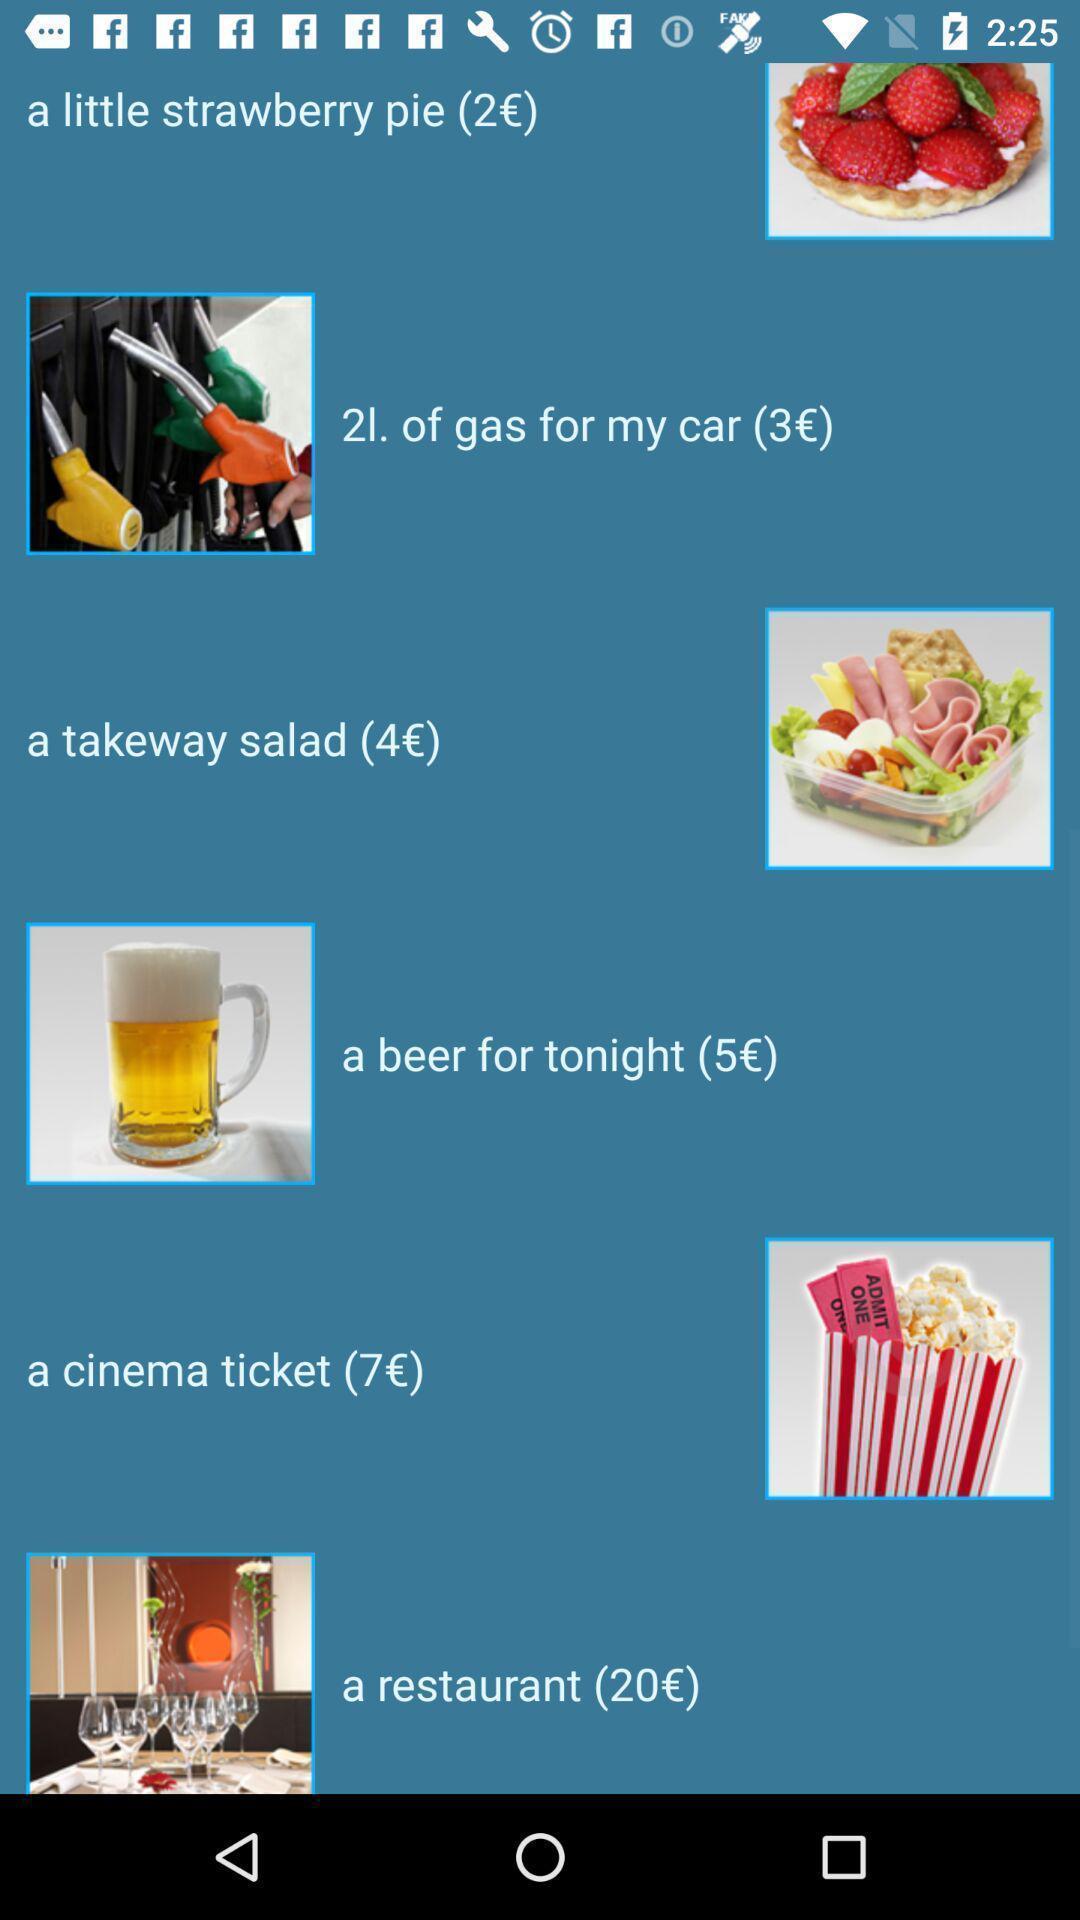Provide a textual representation of this image. Screen displaying a list of items with price. 